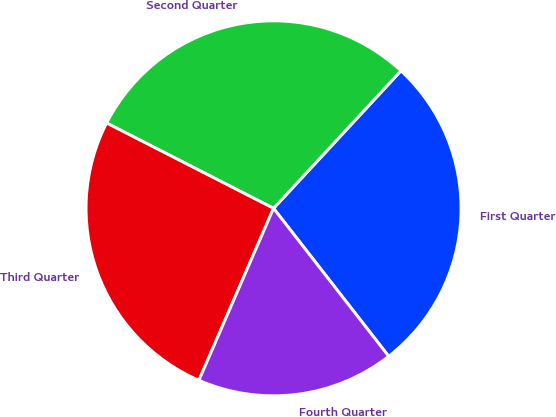<chart> <loc_0><loc_0><loc_500><loc_500><pie_chart><fcel>First Quarter<fcel>Second Quarter<fcel>Third Quarter<fcel>Fourth Quarter<nl><fcel>27.58%<fcel>29.37%<fcel>26.0%<fcel>17.04%<nl></chart> 